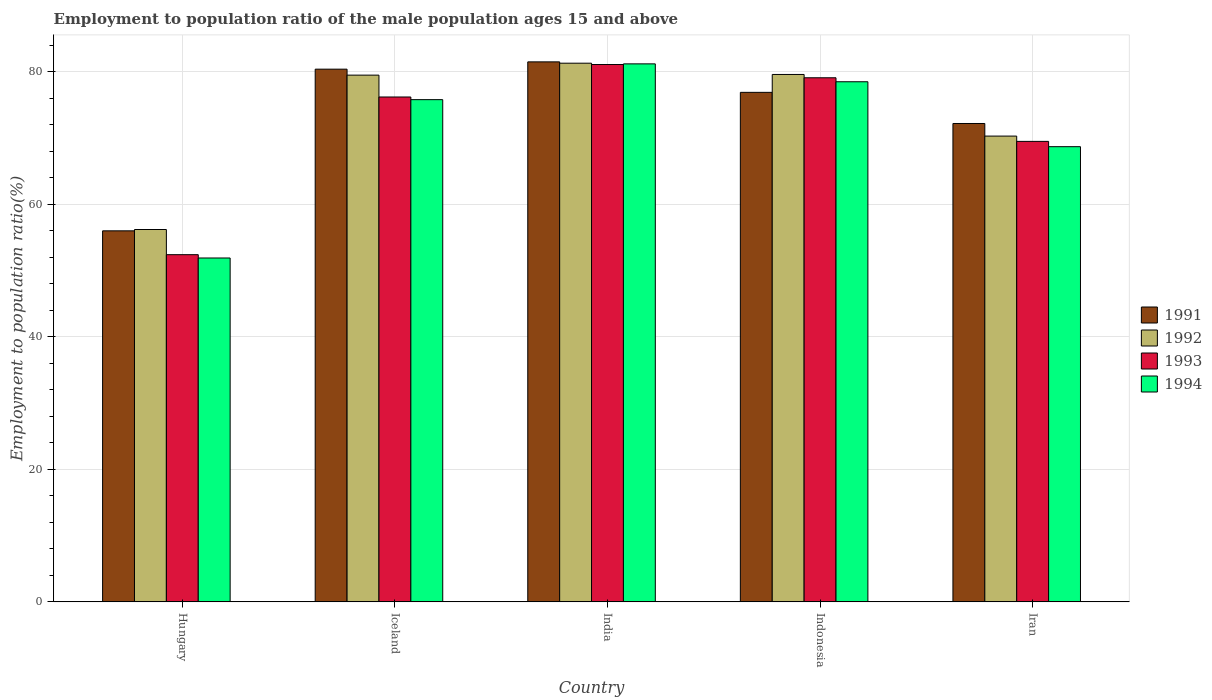How many different coloured bars are there?
Your answer should be compact. 4. Are the number of bars per tick equal to the number of legend labels?
Give a very brief answer. Yes. Are the number of bars on each tick of the X-axis equal?
Offer a terse response. Yes. How many bars are there on the 4th tick from the right?
Offer a very short reply. 4. What is the label of the 5th group of bars from the left?
Your response must be concise. Iran. In how many cases, is the number of bars for a given country not equal to the number of legend labels?
Your answer should be compact. 0. What is the employment to population ratio in 1994 in Hungary?
Offer a terse response. 51.9. Across all countries, what is the maximum employment to population ratio in 1991?
Make the answer very short. 81.5. Across all countries, what is the minimum employment to population ratio in 1993?
Your answer should be very brief. 52.4. In which country was the employment to population ratio in 1991 maximum?
Make the answer very short. India. In which country was the employment to population ratio in 1991 minimum?
Ensure brevity in your answer.  Hungary. What is the total employment to population ratio in 1993 in the graph?
Your answer should be compact. 358.3. What is the difference between the employment to population ratio in 1992 in India and the employment to population ratio in 1993 in Indonesia?
Your answer should be compact. 2.2. What is the average employment to population ratio in 1994 per country?
Give a very brief answer. 71.22. What is the difference between the employment to population ratio of/in 1991 and employment to population ratio of/in 1992 in Iceland?
Your response must be concise. 0.9. In how many countries, is the employment to population ratio in 1993 greater than 64 %?
Make the answer very short. 4. What is the ratio of the employment to population ratio in 1993 in Iceland to that in Indonesia?
Make the answer very short. 0.96. Is the employment to population ratio in 1994 in Hungary less than that in Iceland?
Your answer should be compact. Yes. Is the difference between the employment to population ratio in 1991 in Hungary and Indonesia greater than the difference between the employment to population ratio in 1992 in Hungary and Indonesia?
Your response must be concise. Yes. What is the difference between the highest and the second highest employment to population ratio in 1991?
Make the answer very short. -1.1. What is the difference between the highest and the lowest employment to population ratio in 1993?
Ensure brevity in your answer.  28.7. Is the sum of the employment to population ratio in 1992 in Iceland and India greater than the maximum employment to population ratio in 1991 across all countries?
Your response must be concise. Yes. Is it the case that in every country, the sum of the employment to population ratio in 1992 and employment to population ratio in 1991 is greater than the sum of employment to population ratio in 1993 and employment to population ratio in 1994?
Provide a short and direct response. No. What does the 1st bar from the left in Iceland represents?
Your response must be concise. 1991. Is it the case that in every country, the sum of the employment to population ratio in 1992 and employment to population ratio in 1994 is greater than the employment to population ratio in 1993?
Your response must be concise. Yes. How many bars are there?
Keep it short and to the point. 20. What is the difference between two consecutive major ticks on the Y-axis?
Your answer should be very brief. 20. Are the values on the major ticks of Y-axis written in scientific E-notation?
Provide a succinct answer. No. Where does the legend appear in the graph?
Keep it short and to the point. Center right. What is the title of the graph?
Ensure brevity in your answer.  Employment to population ratio of the male population ages 15 and above. Does "1974" appear as one of the legend labels in the graph?
Your answer should be very brief. No. What is the Employment to population ratio(%) in 1992 in Hungary?
Offer a terse response. 56.2. What is the Employment to population ratio(%) in 1993 in Hungary?
Give a very brief answer. 52.4. What is the Employment to population ratio(%) of 1994 in Hungary?
Your answer should be compact. 51.9. What is the Employment to population ratio(%) in 1991 in Iceland?
Provide a succinct answer. 80.4. What is the Employment to population ratio(%) in 1992 in Iceland?
Your answer should be compact. 79.5. What is the Employment to population ratio(%) in 1993 in Iceland?
Make the answer very short. 76.2. What is the Employment to population ratio(%) of 1994 in Iceland?
Provide a succinct answer. 75.8. What is the Employment to population ratio(%) of 1991 in India?
Ensure brevity in your answer.  81.5. What is the Employment to population ratio(%) in 1992 in India?
Ensure brevity in your answer.  81.3. What is the Employment to population ratio(%) in 1993 in India?
Provide a succinct answer. 81.1. What is the Employment to population ratio(%) in 1994 in India?
Provide a short and direct response. 81.2. What is the Employment to population ratio(%) of 1991 in Indonesia?
Make the answer very short. 76.9. What is the Employment to population ratio(%) of 1992 in Indonesia?
Ensure brevity in your answer.  79.6. What is the Employment to population ratio(%) of 1993 in Indonesia?
Your response must be concise. 79.1. What is the Employment to population ratio(%) in 1994 in Indonesia?
Offer a very short reply. 78.5. What is the Employment to population ratio(%) in 1991 in Iran?
Offer a very short reply. 72.2. What is the Employment to population ratio(%) of 1992 in Iran?
Ensure brevity in your answer.  70.3. What is the Employment to population ratio(%) of 1993 in Iran?
Provide a short and direct response. 69.5. What is the Employment to population ratio(%) of 1994 in Iran?
Make the answer very short. 68.7. Across all countries, what is the maximum Employment to population ratio(%) of 1991?
Provide a short and direct response. 81.5. Across all countries, what is the maximum Employment to population ratio(%) in 1992?
Keep it short and to the point. 81.3. Across all countries, what is the maximum Employment to population ratio(%) of 1993?
Give a very brief answer. 81.1. Across all countries, what is the maximum Employment to population ratio(%) in 1994?
Offer a terse response. 81.2. Across all countries, what is the minimum Employment to population ratio(%) of 1992?
Offer a terse response. 56.2. Across all countries, what is the minimum Employment to population ratio(%) of 1993?
Your response must be concise. 52.4. Across all countries, what is the minimum Employment to population ratio(%) in 1994?
Your response must be concise. 51.9. What is the total Employment to population ratio(%) of 1991 in the graph?
Your answer should be very brief. 367. What is the total Employment to population ratio(%) in 1992 in the graph?
Your answer should be compact. 366.9. What is the total Employment to population ratio(%) in 1993 in the graph?
Keep it short and to the point. 358.3. What is the total Employment to population ratio(%) of 1994 in the graph?
Offer a very short reply. 356.1. What is the difference between the Employment to population ratio(%) in 1991 in Hungary and that in Iceland?
Make the answer very short. -24.4. What is the difference between the Employment to population ratio(%) of 1992 in Hungary and that in Iceland?
Provide a short and direct response. -23.3. What is the difference between the Employment to population ratio(%) of 1993 in Hungary and that in Iceland?
Offer a terse response. -23.8. What is the difference between the Employment to population ratio(%) of 1994 in Hungary and that in Iceland?
Your answer should be very brief. -23.9. What is the difference between the Employment to population ratio(%) of 1991 in Hungary and that in India?
Provide a short and direct response. -25.5. What is the difference between the Employment to population ratio(%) of 1992 in Hungary and that in India?
Make the answer very short. -25.1. What is the difference between the Employment to population ratio(%) in 1993 in Hungary and that in India?
Keep it short and to the point. -28.7. What is the difference between the Employment to population ratio(%) of 1994 in Hungary and that in India?
Your answer should be very brief. -29.3. What is the difference between the Employment to population ratio(%) of 1991 in Hungary and that in Indonesia?
Offer a very short reply. -20.9. What is the difference between the Employment to population ratio(%) in 1992 in Hungary and that in Indonesia?
Your response must be concise. -23.4. What is the difference between the Employment to population ratio(%) in 1993 in Hungary and that in Indonesia?
Provide a succinct answer. -26.7. What is the difference between the Employment to population ratio(%) in 1994 in Hungary and that in Indonesia?
Give a very brief answer. -26.6. What is the difference between the Employment to population ratio(%) in 1991 in Hungary and that in Iran?
Provide a short and direct response. -16.2. What is the difference between the Employment to population ratio(%) of 1992 in Hungary and that in Iran?
Offer a very short reply. -14.1. What is the difference between the Employment to population ratio(%) in 1993 in Hungary and that in Iran?
Your answer should be very brief. -17.1. What is the difference between the Employment to population ratio(%) in 1994 in Hungary and that in Iran?
Ensure brevity in your answer.  -16.8. What is the difference between the Employment to population ratio(%) in 1991 in Iceland and that in India?
Your answer should be very brief. -1.1. What is the difference between the Employment to population ratio(%) in 1994 in Iceland and that in India?
Offer a very short reply. -5.4. What is the difference between the Employment to population ratio(%) of 1992 in Iceland and that in Indonesia?
Keep it short and to the point. -0.1. What is the difference between the Employment to population ratio(%) in 1994 in Iceland and that in Indonesia?
Your response must be concise. -2.7. What is the difference between the Employment to population ratio(%) in 1991 in India and that in Indonesia?
Your answer should be compact. 4.6. What is the difference between the Employment to population ratio(%) in 1992 in India and that in Indonesia?
Keep it short and to the point. 1.7. What is the difference between the Employment to population ratio(%) of 1994 in India and that in Indonesia?
Your response must be concise. 2.7. What is the difference between the Employment to population ratio(%) of 1991 in India and that in Iran?
Ensure brevity in your answer.  9.3. What is the difference between the Employment to population ratio(%) of 1994 in India and that in Iran?
Your answer should be compact. 12.5. What is the difference between the Employment to population ratio(%) of 1991 in Indonesia and that in Iran?
Ensure brevity in your answer.  4.7. What is the difference between the Employment to population ratio(%) of 1992 in Indonesia and that in Iran?
Make the answer very short. 9.3. What is the difference between the Employment to population ratio(%) in 1994 in Indonesia and that in Iran?
Your answer should be very brief. 9.8. What is the difference between the Employment to population ratio(%) in 1991 in Hungary and the Employment to population ratio(%) in 1992 in Iceland?
Make the answer very short. -23.5. What is the difference between the Employment to population ratio(%) of 1991 in Hungary and the Employment to population ratio(%) of 1993 in Iceland?
Make the answer very short. -20.2. What is the difference between the Employment to population ratio(%) in 1991 in Hungary and the Employment to population ratio(%) in 1994 in Iceland?
Your answer should be very brief. -19.8. What is the difference between the Employment to population ratio(%) of 1992 in Hungary and the Employment to population ratio(%) of 1994 in Iceland?
Provide a short and direct response. -19.6. What is the difference between the Employment to population ratio(%) in 1993 in Hungary and the Employment to population ratio(%) in 1994 in Iceland?
Your answer should be compact. -23.4. What is the difference between the Employment to population ratio(%) in 1991 in Hungary and the Employment to population ratio(%) in 1992 in India?
Give a very brief answer. -25.3. What is the difference between the Employment to population ratio(%) in 1991 in Hungary and the Employment to population ratio(%) in 1993 in India?
Your answer should be compact. -25.1. What is the difference between the Employment to population ratio(%) in 1991 in Hungary and the Employment to population ratio(%) in 1994 in India?
Offer a terse response. -25.2. What is the difference between the Employment to population ratio(%) in 1992 in Hungary and the Employment to population ratio(%) in 1993 in India?
Your response must be concise. -24.9. What is the difference between the Employment to population ratio(%) in 1992 in Hungary and the Employment to population ratio(%) in 1994 in India?
Keep it short and to the point. -25. What is the difference between the Employment to population ratio(%) in 1993 in Hungary and the Employment to population ratio(%) in 1994 in India?
Make the answer very short. -28.8. What is the difference between the Employment to population ratio(%) of 1991 in Hungary and the Employment to population ratio(%) of 1992 in Indonesia?
Your response must be concise. -23.6. What is the difference between the Employment to population ratio(%) of 1991 in Hungary and the Employment to population ratio(%) of 1993 in Indonesia?
Make the answer very short. -23.1. What is the difference between the Employment to population ratio(%) in 1991 in Hungary and the Employment to population ratio(%) in 1994 in Indonesia?
Provide a succinct answer. -22.5. What is the difference between the Employment to population ratio(%) in 1992 in Hungary and the Employment to population ratio(%) in 1993 in Indonesia?
Your answer should be compact. -22.9. What is the difference between the Employment to population ratio(%) of 1992 in Hungary and the Employment to population ratio(%) of 1994 in Indonesia?
Your response must be concise. -22.3. What is the difference between the Employment to population ratio(%) of 1993 in Hungary and the Employment to population ratio(%) of 1994 in Indonesia?
Offer a very short reply. -26.1. What is the difference between the Employment to population ratio(%) of 1991 in Hungary and the Employment to population ratio(%) of 1992 in Iran?
Ensure brevity in your answer.  -14.3. What is the difference between the Employment to population ratio(%) of 1991 in Hungary and the Employment to population ratio(%) of 1993 in Iran?
Offer a very short reply. -13.5. What is the difference between the Employment to population ratio(%) of 1992 in Hungary and the Employment to population ratio(%) of 1994 in Iran?
Keep it short and to the point. -12.5. What is the difference between the Employment to population ratio(%) in 1993 in Hungary and the Employment to population ratio(%) in 1994 in Iran?
Ensure brevity in your answer.  -16.3. What is the difference between the Employment to population ratio(%) in 1991 in Iceland and the Employment to population ratio(%) in 1993 in India?
Offer a terse response. -0.7. What is the difference between the Employment to population ratio(%) of 1991 in Iceland and the Employment to population ratio(%) of 1994 in India?
Offer a very short reply. -0.8. What is the difference between the Employment to population ratio(%) of 1992 in Iceland and the Employment to population ratio(%) of 1993 in Indonesia?
Offer a very short reply. 0.4. What is the difference between the Employment to population ratio(%) of 1992 in Iceland and the Employment to population ratio(%) of 1994 in Indonesia?
Make the answer very short. 1. What is the difference between the Employment to population ratio(%) of 1993 in Iceland and the Employment to population ratio(%) of 1994 in Indonesia?
Keep it short and to the point. -2.3. What is the difference between the Employment to population ratio(%) in 1991 in Iceland and the Employment to population ratio(%) in 1992 in Iran?
Give a very brief answer. 10.1. What is the difference between the Employment to population ratio(%) in 1991 in Iceland and the Employment to population ratio(%) in 1994 in Iran?
Provide a short and direct response. 11.7. What is the difference between the Employment to population ratio(%) in 1992 in Iceland and the Employment to population ratio(%) in 1993 in Iran?
Offer a terse response. 10. What is the difference between the Employment to population ratio(%) in 1992 in Iceland and the Employment to population ratio(%) in 1994 in Iran?
Your response must be concise. 10.8. What is the difference between the Employment to population ratio(%) in 1991 in India and the Employment to population ratio(%) in 1992 in Indonesia?
Provide a short and direct response. 1.9. What is the difference between the Employment to population ratio(%) of 1991 in India and the Employment to population ratio(%) of 1993 in Indonesia?
Offer a terse response. 2.4. What is the difference between the Employment to population ratio(%) in 1991 in India and the Employment to population ratio(%) in 1994 in Indonesia?
Offer a terse response. 3. What is the difference between the Employment to population ratio(%) of 1992 in India and the Employment to population ratio(%) of 1993 in Indonesia?
Your answer should be very brief. 2.2. What is the difference between the Employment to population ratio(%) in 1993 in India and the Employment to population ratio(%) in 1994 in Indonesia?
Keep it short and to the point. 2.6. What is the difference between the Employment to population ratio(%) of 1991 in India and the Employment to population ratio(%) of 1994 in Iran?
Your answer should be compact. 12.8. What is the difference between the Employment to population ratio(%) of 1993 in India and the Employment to population ratio(%) of 1994 in Iran?
Keep it short and to the point. 12.4. What is the difference between the Employment to population ratio(%) of 1991 in Indonesia and the Employment to population ratio(%) of 1993 in Iran?
Give a very brief answer. 7.4. What is the difference between the Employment to population ratio(%) of 1991 in Indonesia and the Employment to population ratio(%) of 1994 in Iran?
Your response must be concise. 8.2. What is the difference between the Employment to population ratio(%) in 1992 in Indonesia and the Employment to population ratio(%) in 1994 in Iran?
Make the answer very short. 10.9. What is the average Employment to population ratio(%) in 1991 per country?
Offer a very short reply. 73.4. What is the average Employment to population ratio(%) of 1992 per country?
Give a very brief answer. 73.38. What is the average Employment to population ratio(%) of 1993 per country?
Your response must be concise. 71.66. What is the average Employment to population ratio(%) of 1994 per country?
Offer a very short reply. 71.22. What is the difference between the Employment to population ratio(%) in 1991 and Employment to population ratio(%) in 1993 in Hungary?
Provide a succinct answer. 3.6. What is the difference between the Employment to population ratio(%) of 1991 and Employment to population ratio(%) of 1994 in Hungary?
Your answer should be compact. 4.1. What is the difference between the Employment to population ratio(%) in 1992 and Employment to population ratio(%) in 1994 in Hungary?
Give a very brief answer. 4.3. What is the difference between the Employment to population ratio(%) in 1991 and Employment to population ratio(%) in 1992 in Iceland?
Your answer should be compact. 0.9. What is the difference between the Employment to population ratio(%) of 1991 and Employment to population ratio(%) of 1993 in Iceland?
Ensure brevity in your answer.  4.2. What is the difference between the Employment to population ratio(%) in 1992 and Employment to population ratio(%) in 1993 in Iceland?
Provide a succinct answer. 3.3. What is the difference between the Employment to population ratio(%) of 1993 and Employment to population ratio(%) of 1994 in Iceland?
Make the answer very short. 0.4. What is the difference between the Employment to population ratio(%) in 1991 and Employment to population ratio(%) in 1993 in India?
Ensure brevity in your answer.  0.4. What is the difference between the Employment to population ratio(%) in 1991 and Employment to population ratio(%) in 1994 in India?
Your answer should be compact. 0.3. What is the difference between the Employment to population ratio(%) in 1992 and Employment to population ratio(%) in 1993 in India?
Your answer should be compact. 0.2. What is the difference between the Employment to population ratio(%) in 1992 and Employment to population ratio(%) in 1994 in India?
Your answer should be very brief. 0.1. What is the difference between the Employment to population ratio(%) in 1993 and Employment to population ratio(%) in 1994 in India?
Provide a short and direct response. -0.1. What is the difference between the Employment to population ratio(%) in 1991 and Employment to population ratio(%) in 1993 in Indonesia?
Offer a terse response. -2.2. What is the difference between the Employment to population ratio(%) of 1991 and Employment to population ratio(%) of 1994 in Indonesia?
Your answer should be compact. -1.6. What is the difference between the Employment to population ratio(%) of 1992 and Employment to population ratio(%) of 1993 in Indonesia?
Your response must be concise. 0.5. What is the difference between the Employment to population ratio(%) in 1991 and Employment to population ratio(%) in 1993 in Iran?
Your answer should be compact. 2.7. What is the difference between the Employment to population ratio(%) in 1992 and Employment to population ratio(%) in 1993 in Iran?
Keep it short and to the point. 0.8. What is the ratio of the Employment to population ratio(%) in 1991 in Hungary to that in Iceland?
Keep it short and to the point. 0.7. What is the ratio of the Employment to population ratio(%) in 1992 in Hungary to that in Iceland?
Provide a succinct answer. 0.71. What is the ratio of the Employment to population ratio(%) of 1993 in Hungary to that in Iceland?
Your answer should be very brief. 0.69. What is the ratio of the Employment to population ratio(%) of 1994 in Hungary to that in Iceland?
Keep it short and to the point. 0.68. What is the ratio of the Employment to population ratio(%) of 1991 in Hungary to that in India?
Provide a succinct answer. 0.69. What is the ratio of the Employment to population ratio(%) in 1992 in Hungary to that in India?
Provide a short and direct response. 0.69. What is the ratio of the Employment to population ratio(%) in 1993 in Hungary to that in India?
Give a very brief answer. 0.65. What is the ratio of the Employment to population ratio(%) of 1994 in Hungary to that in India?
Ensure brevity in your answer.  0.64. What is the ratio of the Employment to population ratio(%) in 1991 in Hungary to that in Indonesia?
Offer a very short reply. 0.73. What is the ratio of the Employment to population ratio(%) in 1992 in Hungary to that in Indonesia?
Offer a terse response. 0.71. What is the ratio of the Employment to population ratio(%) of 1993 in Hungary to that in Indonesia?
Your answer should be compact. 0.66. What is the ratio of the Employment to population ratio(%) in 1994 in Hungary to that in Indonesia?
Offer a very short reply. 0.66. What is the ratio of the Employment to population ratio(%) in 1991 in Hungary to that in Iran?
Offer a terse response. 0.78. What is the ratio of the Employment to population ratio(%) of 1992 in Hungary to that in Iran?
Offer a terse response. 0.8. What is the ratio of the Employment to population ratio(%) of 1993 in Hungary to that in Iran?
Keep it short and to the point. 0.75. What is the ratio of the Employment to population ratio(%) of 1994 in Hungary to that in Iran?
Ensure brevity in your answer.  0.76. What is the ratio of the Employment to population ratio(%) in 1991 in Iceland to that in India?
Offer a very short reply. 0.99. What is the ratio of the Employment to population ratio(%) of 1992 in Iceland to that in India?
Your response must be concise. 0.98. What is the ratio of the Employment to population ratio(%) in 1993 in Iceland to that in India?
Provide a short and direct response. 0.94. What is the ratio of the Employment to population ratio(%) in 1994 in Iceland to that in India?
Provide a succinct answer. 0.93. What is the ratio of the Employment to population ratio(%) in 1991 in Iceland to that in Indonesia?
Offer a very short reply. 1.05. What is the ratio of the Employment to population ratio(%) of 1993 in Iceland to that in Indonesia?
Make the answer very short. 0.96. What is the ratio of the Employment to population ratio(%) in 1994 in Iceland to that in Indonesia?
Keep it short and to the point. 0.97. What is the ratio of the Employment to population ratio(%) of 1991 in Iceland to that in Iran?
Ensure brevity in your answer.  1.11. What is the ratio of the Employment to population ratio(%) in 1992 in Iceland to that in Iran?
Offer a very short reply. 1.13. What is the ratio of the Employment to population ratio(%) of 1993 in Iceland to that in Iran?
Offer a very short reply. 1.1. What is the ratio of the Employment to population ratio(%) of 1994 in Iceland to that in Iran?
Provide a succinct answer. 1.1. What is the ratio of the Employment to population ratio(%) of 1991 in India to that in Indonesia?
Your response must be concise. 1.06. What is the ratio of the Employment to population ratio(%) in 1992 in India to that in Indonesia?
Offer a terse response. 1.02. What is the ratio of the Employment to population ratio(%) of 1993 in India to that in Indonesia?
Give a very brief answer. 1.03. What is the ratio of the Employment to population ratio(%) of 1994 in India to that in Indonesia?
Your answer should be compact. 1.03. What is the ratio of the Employment to population ratio(%) in 1991 in India to that in Iran?
Provide a short and direct response. 1.13. What is the ratio of the Employment to population ratio(%) of 1992 in India to that in Iran?
Your answer should be very brief. 1.16. What is the ratio of the Employment to population ratio(%) in 1993 in India to that in Iran?
Your response must be concise. 1.17. What is the ratio of the Employment to population ratio(%) of 1994 in India to that in Iran?
Your response must be concise. 1.18. What is the ratio of the Employment to population ratio(%) of 1991 in Indonesia to that in Iran?
Your answer should be compact. 1.07. What is the ratio of the Employment to population ratio(%) in 1992 in Indonesia to that in Iran?
Keep it short and to the point. 1.13. What is the ratio of the Employment to population ratio(%) in 1993 in Indonesia to that in Iran?
Your answer should be very brief. 1.14. What is the ratio of the Employment to population ratio(%) of 1994 in Indonesia to that in Iran?
Your answer should be very brief. 1.14. What is the difference between the highest and the second highest Employment to population ratio(%) of 1991?
Make the answer very short. 1.1. What is the difference between the highest and the second highest Employment to population ratio(%) in 1992?
Offer a very short reply. 1.7. What is the difference between the highest and the second highest Employment to population ratio(%) of 1994?
Make the answer very short. 2.7. What is the difference between the highest and the lowest Employment to population ratio(%) of 1991?
Make the answer very short. 25.5. What is the difference between the highest and the lowest Employment to population ratio(%) of 1992?
Make the answer very short. 25.1. What is the difference between the highest and the lowest Employment to population ratio(%) of 1993?
Make the answer very short. 28.7. What is the difference between the highest and the lowest Employment to population ratio(%) of 1994?
Offer a terse response. 29.3. 